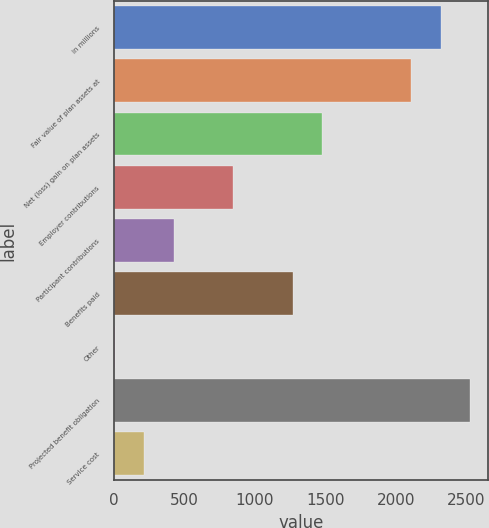Convert chart. <chart><loc_0><loc_0><loc_500><loc_500><bar_chart><fcel>in millions<fcel>Fair value of plan assets at<fcel>Net (loss) gain on plan assets<fcel>Employer contributions<fcel>Participant contributions<fcel>Benefits paid<fcel>Other<fcel>Projected benefit obligation<fcel>Service cost<nl><fcel>2320.7<fcel>2110<fcel>1477.9<fcel>845.8<fcel>424.4<fcel>1267.2<fcel>3<fcel>2531.4<fcel>213.7<nl></chart> 